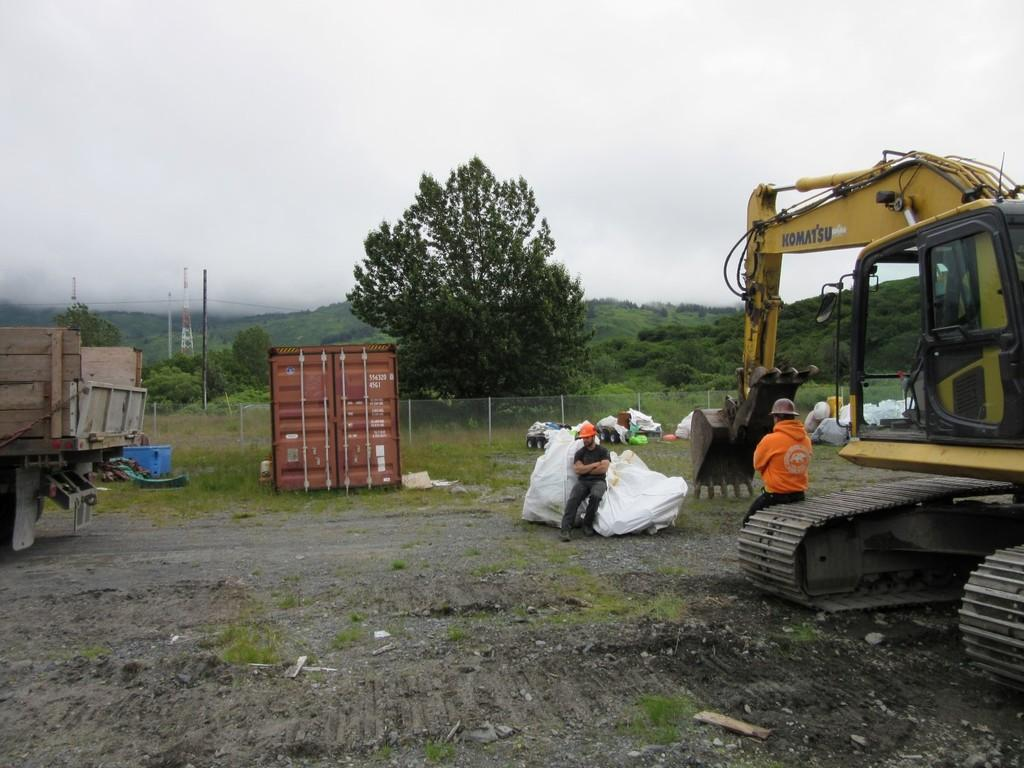<image>
Present a compact description of the photo's key features. A large machine has the word KOMATSU on it. 